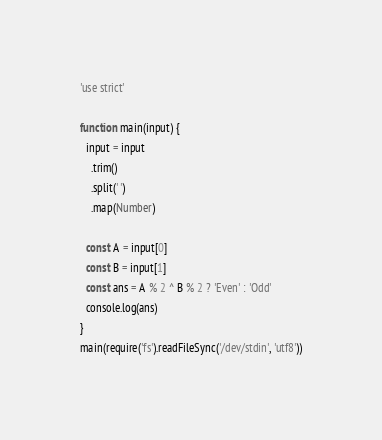<code> <loc_0><loc_0><loc_500><loc_500><_JavaScript_>'use strict'

function main(input) {
  input = input
    .trim()
    .split(' ')
    .map(Number)

  const A = input[0]
  const B = input[1]
  const ans = A % 2 ^ B % 2 ? 'Even' : 'Odd'
  console.log(ans)
}
main(require('fs').readFileSync('/dev/stdin', 'utf8'))
</code> 